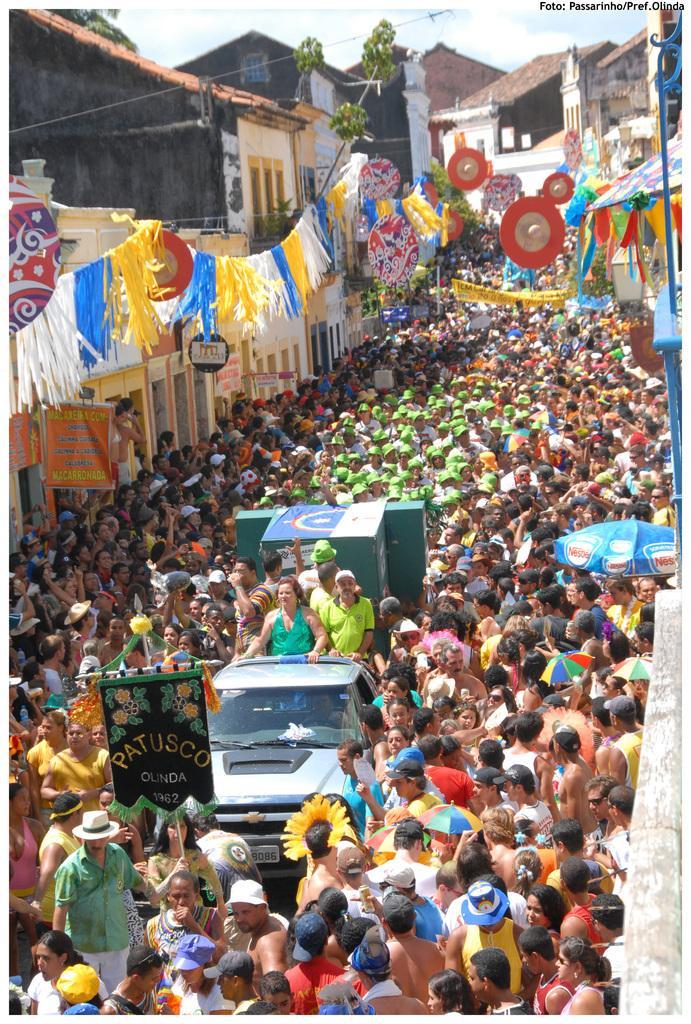In one or two sentences, can you explain what this image depicts? In this image, there is an outside view. There is a crowd in between buildings. There are some persons standing on the vehicle which is in the middle of the image. 